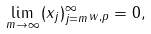<formula> <loc_0><loc_0><loc_500><loc_500>\lim _ { m \rightarrow \infty } \| ( x _ { j } ) _ { j = m } ^ { \infty } \| _ { w , p } = 0 ,</formula> 